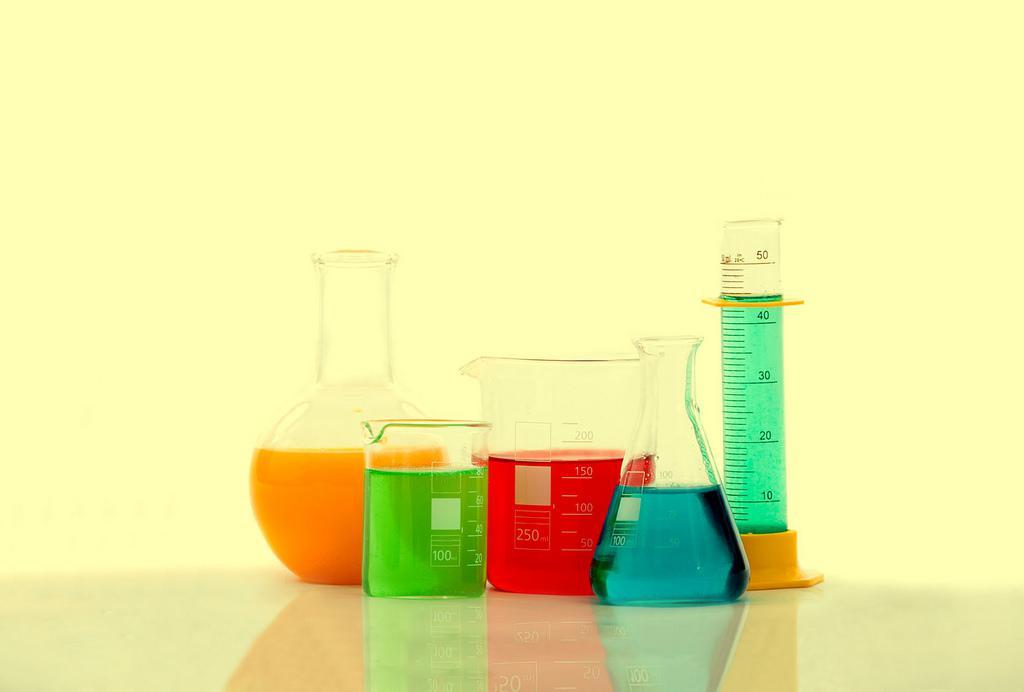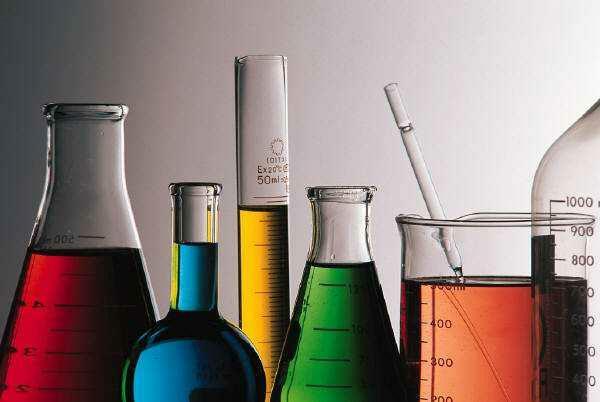The first image is the image on the left, the second image is the image on the right. For the images shown, is this caption "There is at least one beaker straw of stir stick." true? Answer yes or no. Yes. The first image is the image on the left, the second image is the image on the right. For the images displayed, is the sentence "A blue light glows behind the containers in the image on the left." factually correct? Answer yes or no. No. 